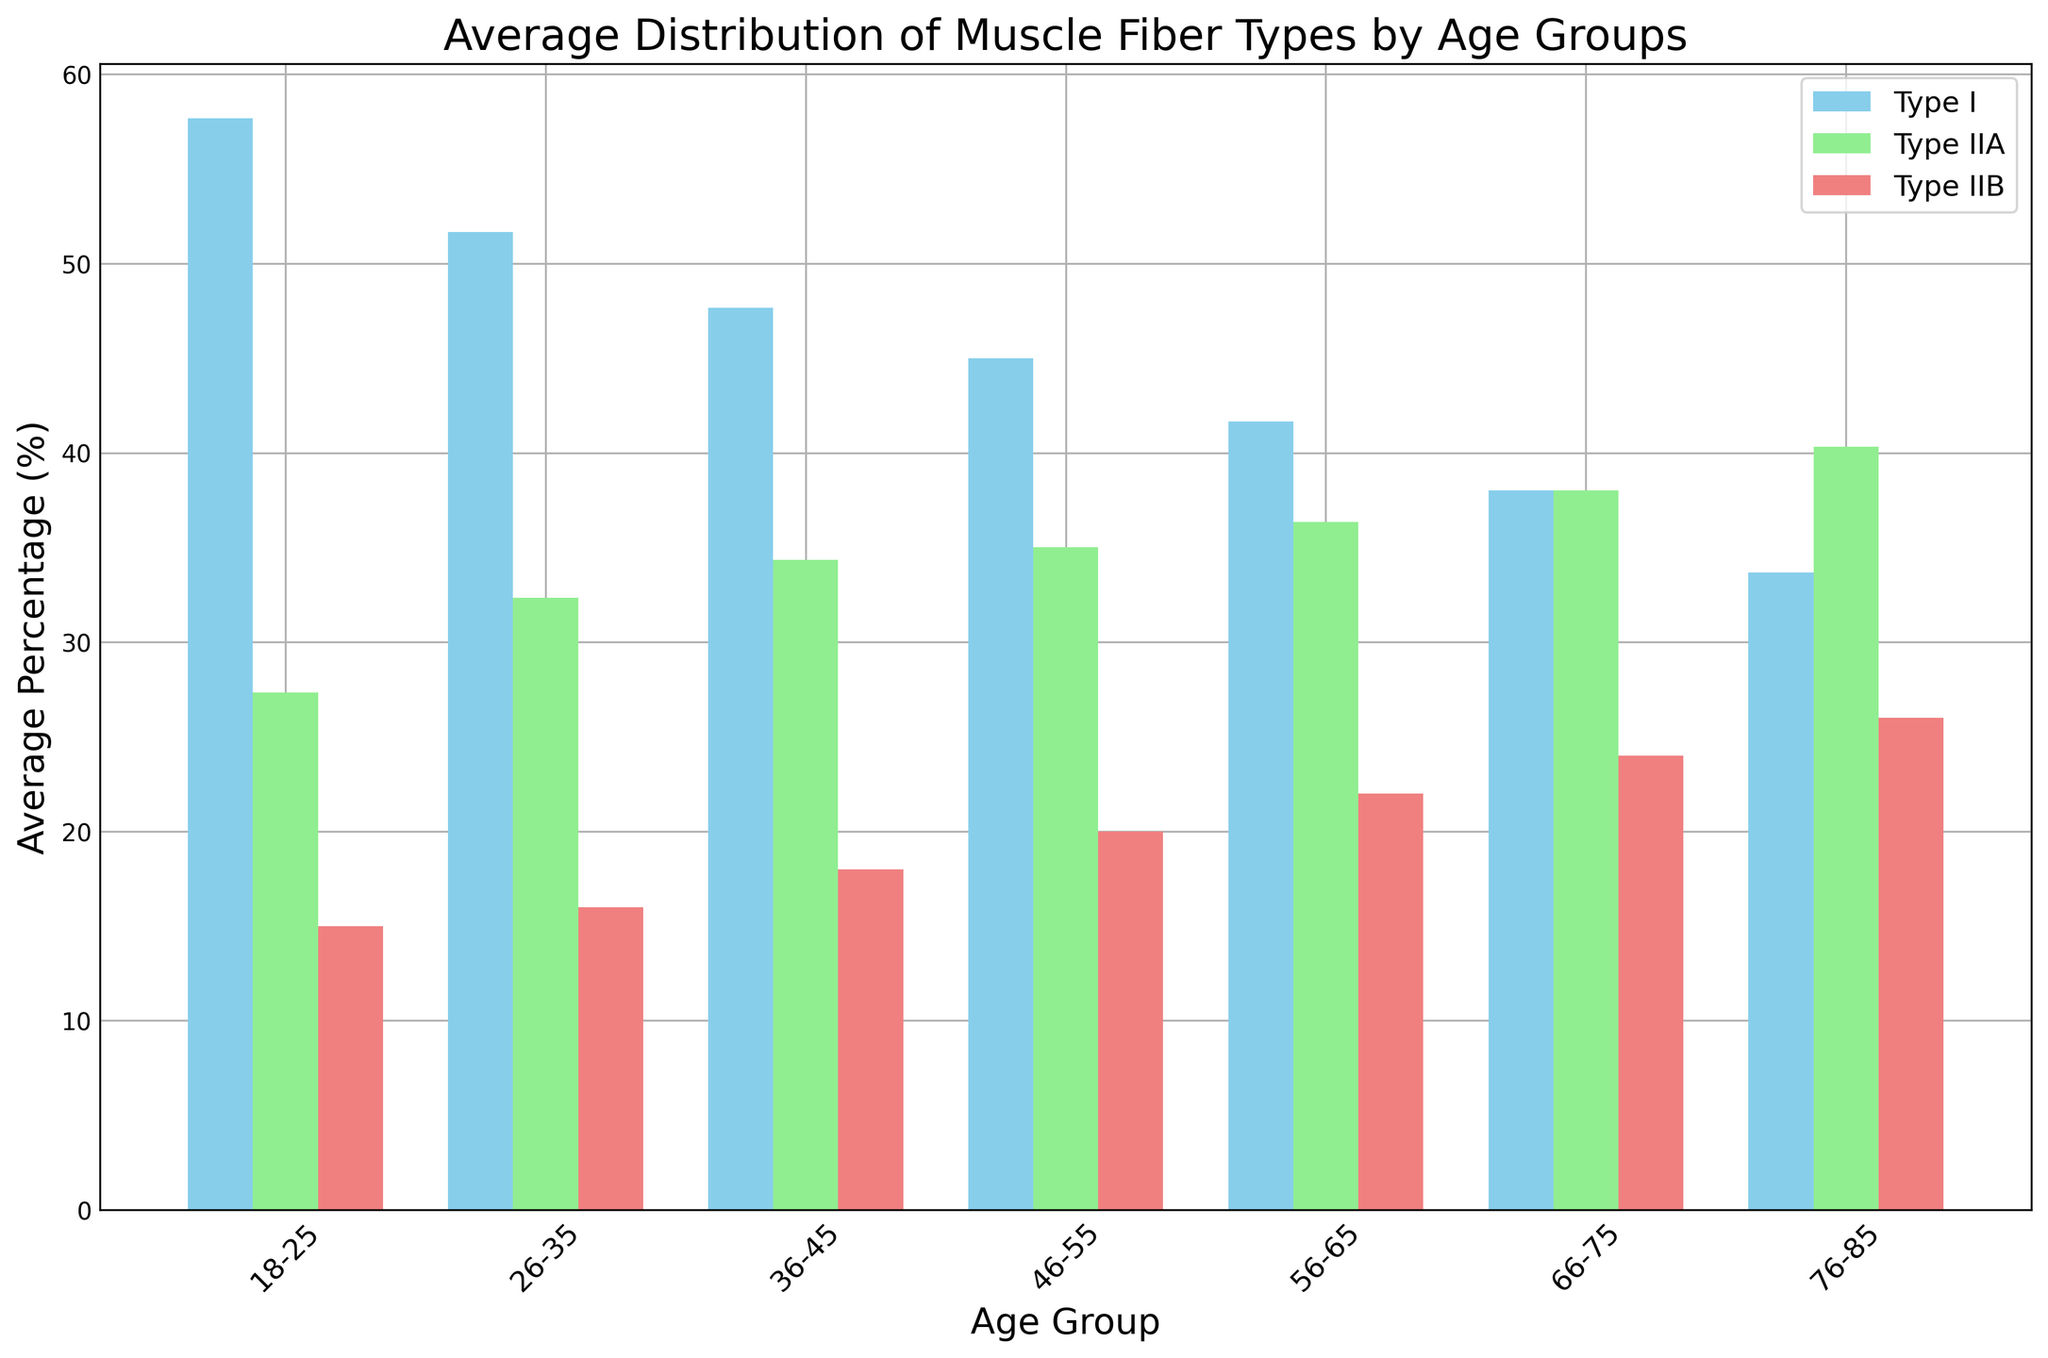What is the average percentage of Type I Fibers for the age group 26-35? To find the average percentage of Type I Fibers for the age group 26-35, sum the percentages for this age group and divide by the number of data points. The percentages are 52, 50, and 53. The sum is 52 + 50 + 53 = 155, and there are 3 data points. So, the average is 155 / 3 = 51.67.
Answer: 51.67 Which age group has the highest average percentage of Type IIB Fibers? Look at the bars corresponding to Type IIB fibers across all age groups. The highest average percentage is represented by the tallest bar, which is in the 76-85 age group at 26%.
Answer: 76-85 In which age group is the difference between Type IIA and Type I Fibers the largest? Calculate the difference between Type IIA and Type I percent for each age group. The differences are: (18-25): 55.33 - 27.33 = 27, (26-35): 51.67 - 32.33 = 19.34, (36-45): 32.66 - 47 = 14.34, (46-55): 34.67 - 45 = 10.33, (56-65): 32.66 - 41.67 = 9.01, (66-75): 23.33 - 38 = -14.67, (76-85): 12.67 - 33.66 = -20.99. The age group 18-25 has the largest difference.
Answer: 18-25 Compare the average percentage of Type IIA and Type I Fibers in the 56-65 age group. Which one is higher? Look at the average percentage bars for Type IIA and Type I Fibers in the 56-65 age group. The average for Type IIA is 36.33 and for Type I is 41.67. Type IIA is lower than Type I.
Answer: Type I What is the sum of the average percentages of Type IIA and Type IIB Fibers in the age group 66-75? Find the average values for Type IIA and Type IIB in the 66-75 age group, which are 38 and 24 respectively. Sum these values: 38 + 24 = 62.
Answer: 62 By how much does the percentage of Type I Fibers decrease from the 18-25 age group to the 76-85 age group? Identify the average percentages of Type I Fibers in 18-25 (57.67) and 76-85 (33.67). Subtract to find the decrease: 57.67 - 33.67 = 24.
Answer: 24 Which fiber type shows the least variation in average percentage across all age groups? Observe the bar lengths for each fiber type across age groups. Type IIB Fiber percentages display the least visual variation since they remain more stable across the age groups.
Answer: Type IIB What is the average percentage of Type I Fibers across all age groups? Sum the average percentages of Type I Fibers for all age groups and divide by the number of age groups. The sum is (57.67 + 51.67 + 47 + 45 + 41.67 + 38 + 33.67) = 314.68. There are 7 age groups, so the average is 314.68 / 7 = 44.96.
Answer: 44.96 